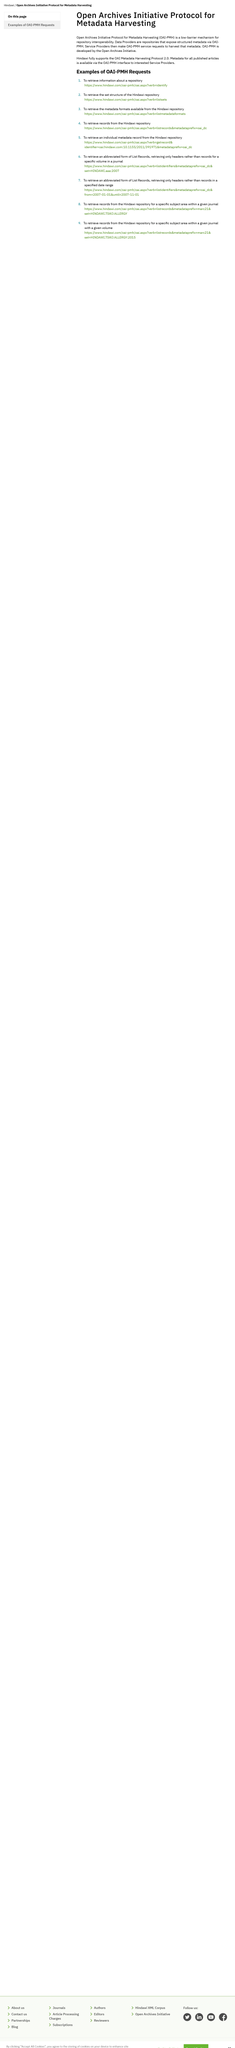Give some essential details in this illustration. The Open Archives Initiative developed the OAI-PMH. Hindawi fully supports the OAI Metadata Harvesting Protocol 2.0. The acronym "OAI-PMH" stands for "Open Archives Initiative Protocol for Metadata Harvesting. 